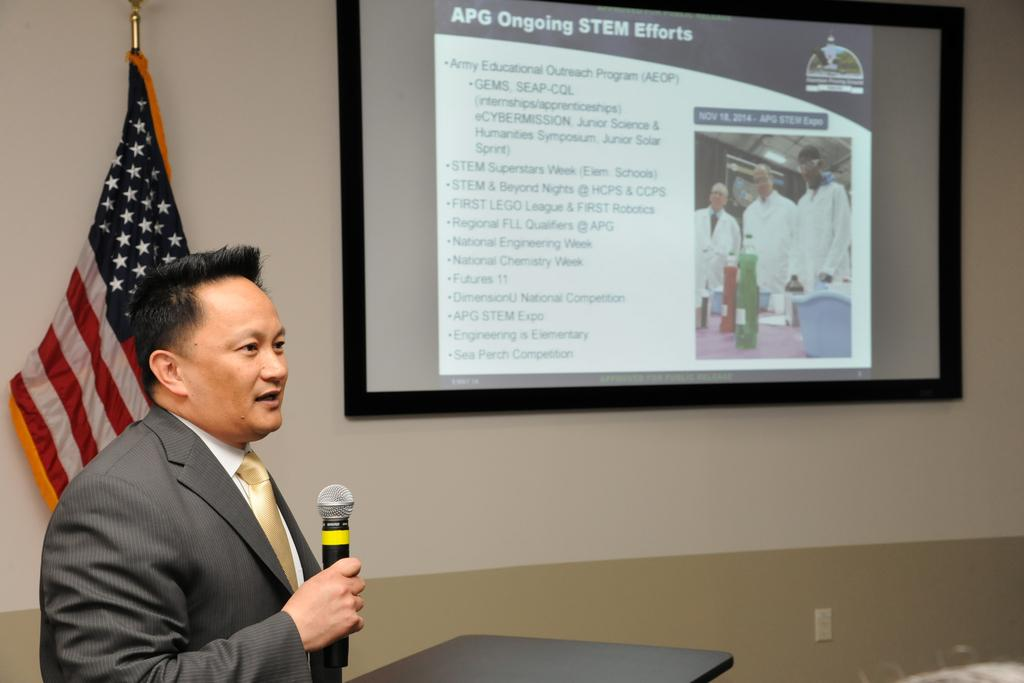What is the man in the image doing? The man is standing and talking in the image. What object is the man holding in the image? The man is holding a microphone in the image. What can be seen hanging from a pole in the image? There is a flag hanging from a pole in the image. What is attached to a wall in the image? There is a screen attached to a wall in the image. What piece of furniture is present in the image? There is a podium in the image. What type of boot is the man wearing in the image? The man is not wearing a boot in the image; he is standing and talking while holding a microphone. Can you see a volleyball being played in the image? There is no volleyball or any indication of a game being played in the image. 